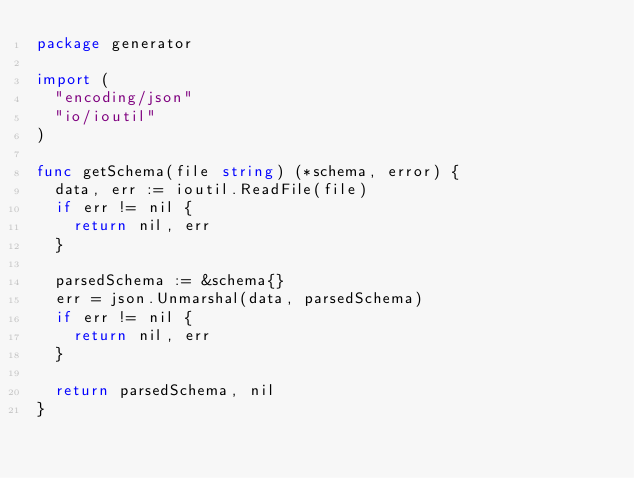Convert code to text. <code><loc_0><loc_0><loc_500><loc_500><_Go_>package generator

import (
	"encoding/json"
	"io/ioutil"
)

func getSchema(file string) (*schema, error) {
	data, err := ioutil.ReadFile(file)
	if err != nil {
		return nil, err
	}

	parsedSchema := &schema{}
	err = json.Unmarshal(data, parsedSchema)
	if err != nil {
		return nil, err
	}

	return parsedSchema, nil
}
</code> 